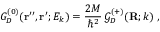Convert formula to latex. <formula><loc_0><loc_0><loc_500><loc_500>G _ { D } ^ { ( 0 ) } ( { r ^ { \prime \prime } } , { r ^ { \prime } } ; E _ { k } ) = \frac { 2 M } { \hbar { ^ } { 2 } } \, { \mathcal { G } } _ { D } ^ { ( + ) } ( { R } ; k ) \, ,</formula> 